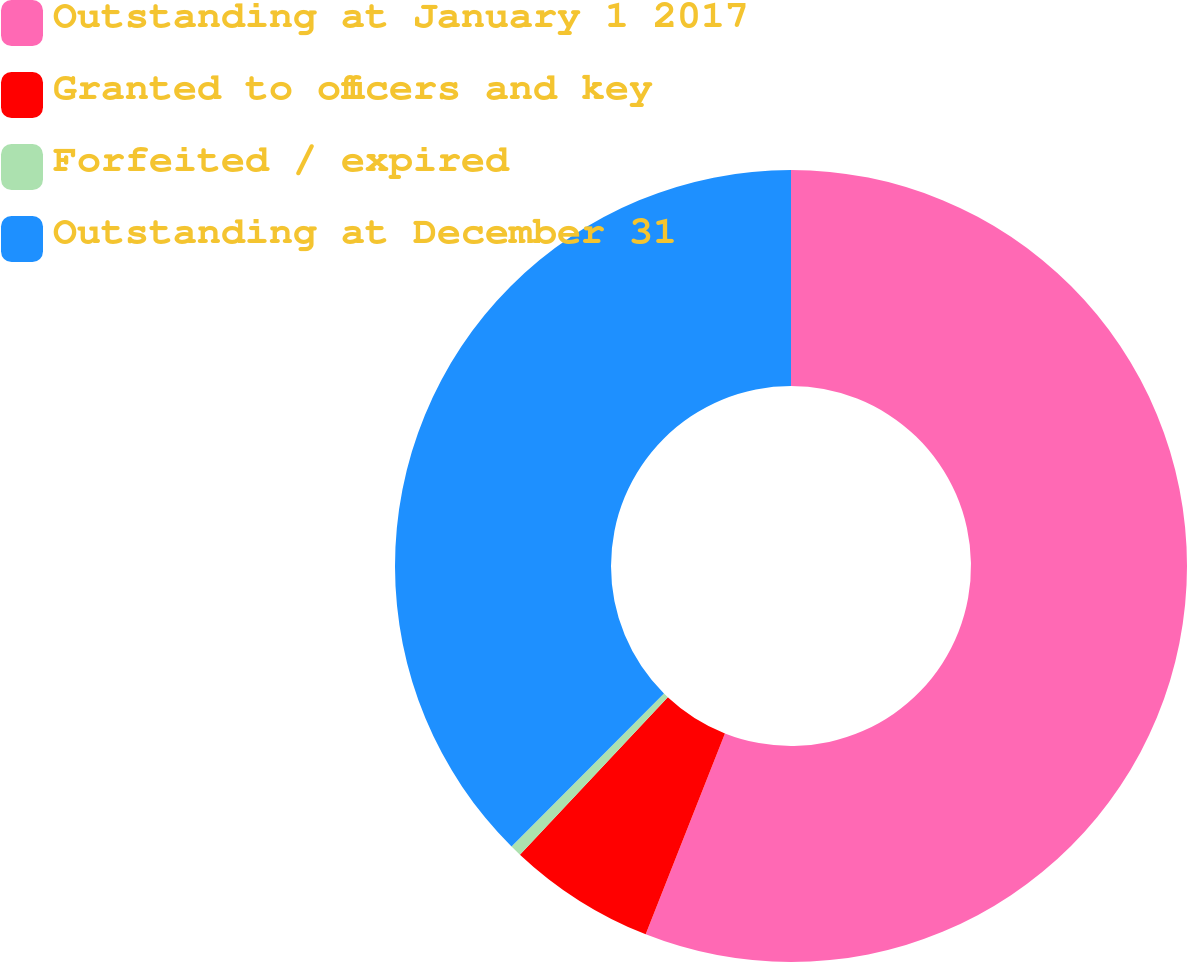Convert chart. <chart><loc_0><loc_0><loc_500><loc_500><pie_chart><fcel>Outstanding at January 1 2017<fcel>Granted to officers and key<fcel>Forfeited / expired<fcel>Outstanding at December 31<nl><fcel>55.98%<fcel>6.02%<fcel>0.47%<fcel>37.53%<nl></chart> 